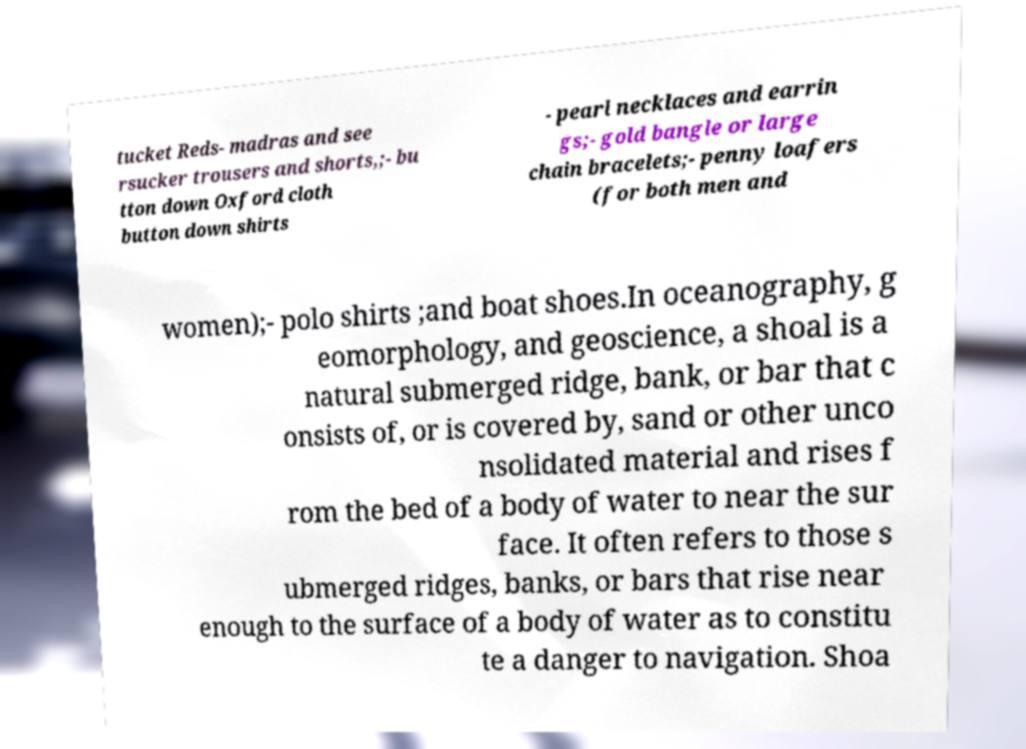There's text embedded in this image that I need extracted. Can you transcribe it verbatim? tucket Reds- madras and see rsucker trousers and shorts,;- bu tton down Oxford cloth button down shirts - pearl necklaces and earrin gs;- gold bangle or large chain bracelets;- penny loafers (for both men and women);- polo shirts ;and boat shoes.In oceanography, g eomorphology, and geoscience, a shoal is a natural submerged ridge, bank, or bar that c onsists of, or is covered by, sand or other unco nsolidated material and rises f rom the bed of a body of water to near the sur face. It often refers to those s ubmerged ridges, banks, or bars that rise near enough to the surface of a body of water as to constitu te a danger to navigation. Shoa 